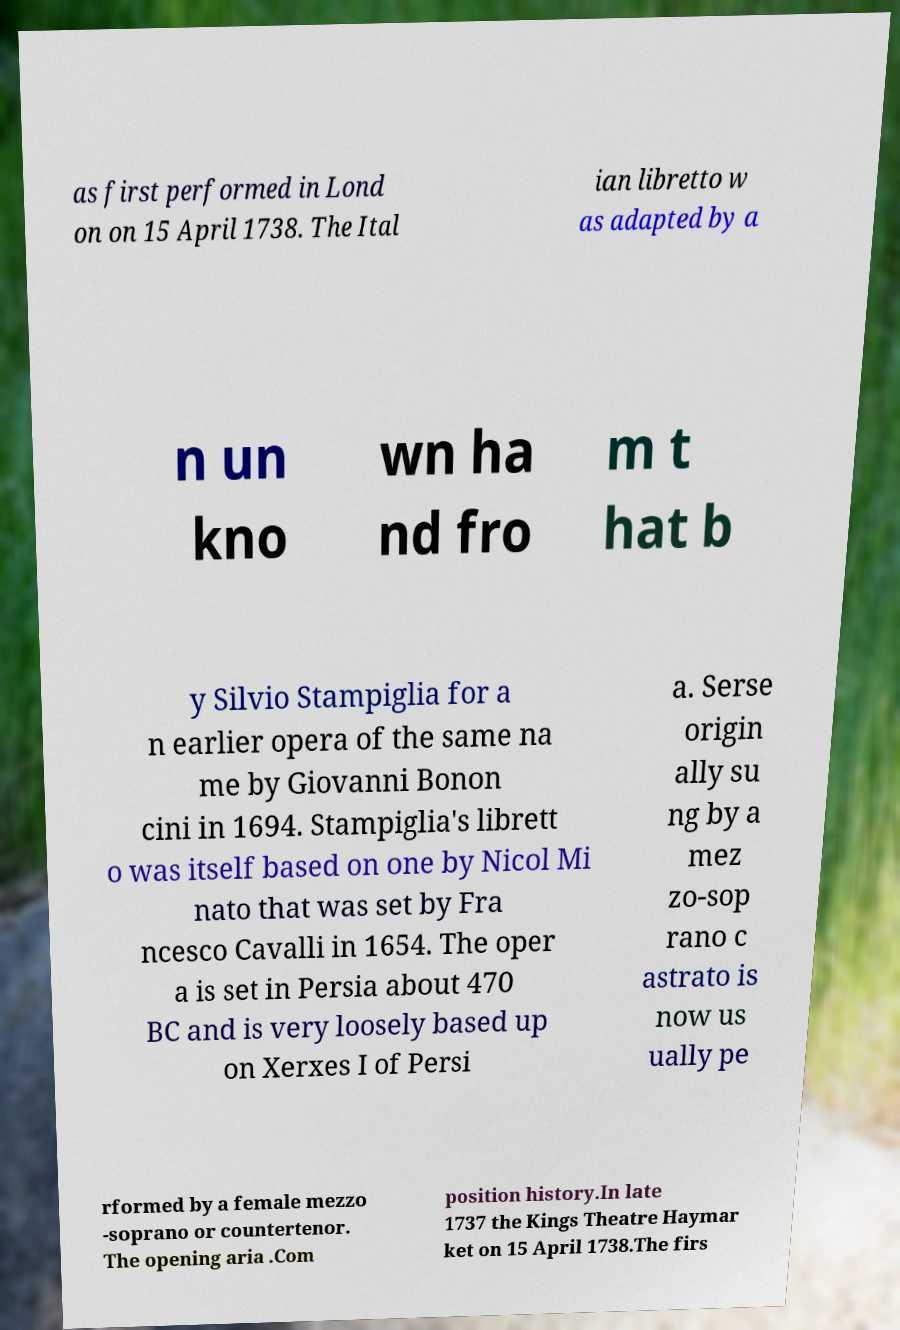What messages or text are displayed in this image? I need them in a readable, typed format. as first performed in Lond on on 15 April 1738. The Ital ian libretto w as adapted by a n un kno wn ha nd fro m t hat b y Silvio Stampiglia for a n earlier opera of the same na me by Giovanni Bonon cini in 1694. Stampiglia's librett o was itself based on one by Nicol Mi nato that was set by Fra ncesco Cavalli in 1654. The oper a is set in Persia about 470 BC and is very loosely based up on Xerxes I of Persi a. Serse origin ally su ng by a mez zo-sop rano c astrato is now us ually pe rformed by a female mezzo -soprano or countertenor. The opening aria .Com position history.In late 1737 the Kings Theatre Haymar ket on 15 April 1738.The firs 